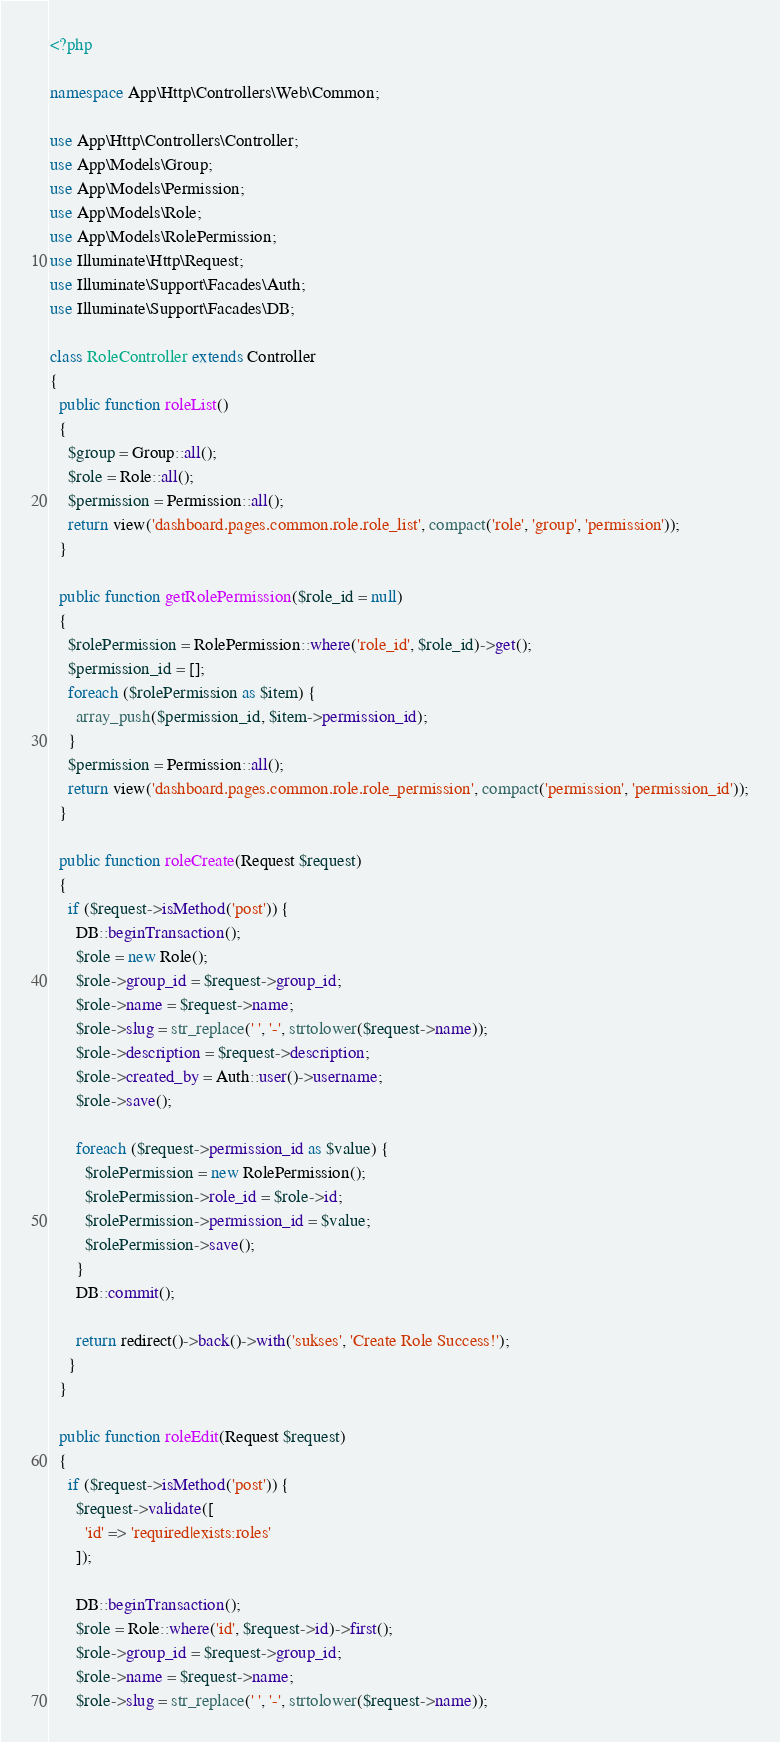<code> <loc_0><loc_0><loc_500><loc_500><_PHP_><?php

namespace App\Http\Controllers\Web\Common;

use App\Http\Controllers\Controller;
use App\Models\Group;
use App\Models\Permission;
use App\Models\Role;
use App\Models\RolePermission;
use Illuminate\Http\Request;
use Illuminate\Support\Facades\Auth;
use Illuminate\Support\Facades\DB;

class RoleController extends Controller
{
  public function roleList()
  {
    $group = Group::all();
    $role = Role::all();
    $permission = Permission::all();
    return view('dashboard.pages.common.role.role_list', compact('role', 'group', 'permission'));
  }

  public function getRolePermission($role_id = null)
  {
    $rolePermission = RolePermission::where('role_id', $role_id)->get();
    $permission_id = [];
    foreach ($rolePermission as $item) {
      array_push($permission_id, $item->permission_id);
    }
    $permission = Permission::all();
    return view('dashboard.pages.common.role.role_permission', compact('permission', 'permission_id'));
  }

  public function roleCreate(Request $request)
  {
    if ($request->isMethod('post')) {
      DB::beginTransaction();
      $role = new Role();
      $role->group_id = $request->group_id;
      $role->name = $request->name;
      $role->slug = str_replace(' ', '-', strtolower($request->name));
      $role->description = $request->description;
      $role->created_by = Auth::user()->username;
      $role->save();

      foreach ($request->permission_id as $value) {
        $rolePermission = new RolePermission();
        $rolePermission->role_id = $role->id;
        $rolePermission->permission_id = $value;
        $rolePermission->save();
      }
      DB::commit();

      return redirect()->back()->with('sukses', 'Create Role Success!');
    }
  }

  public function roleEdit(Request $request)
  {
    if ($request->isMethod('post')) {
      $request->validate([
        'id' => 'required|exists:roles'
      ]);

      DB::beginTransaction();
      $role = Role::where('id', $request->id)->first();
      $role->group_id = $request->group_id;
      $role->name = $request->name;
      $role->slug = str_replace(' ', '-', strtolower($request->name));</code> 